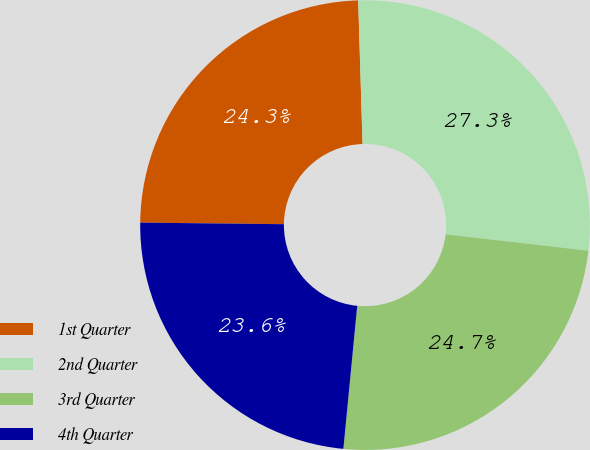Convert chart. <chart><loc_0><loc_0><loc_500><loc_500><pie_chart><fcel>1st Quarter<fcel>2nd Quarter<fcel>3rd Quarter<fcel>4th Quarter<nl><fcel>24.34%<fcel>27.3%<fcel>24.72%<fcel>23.64%<nl></chart> 